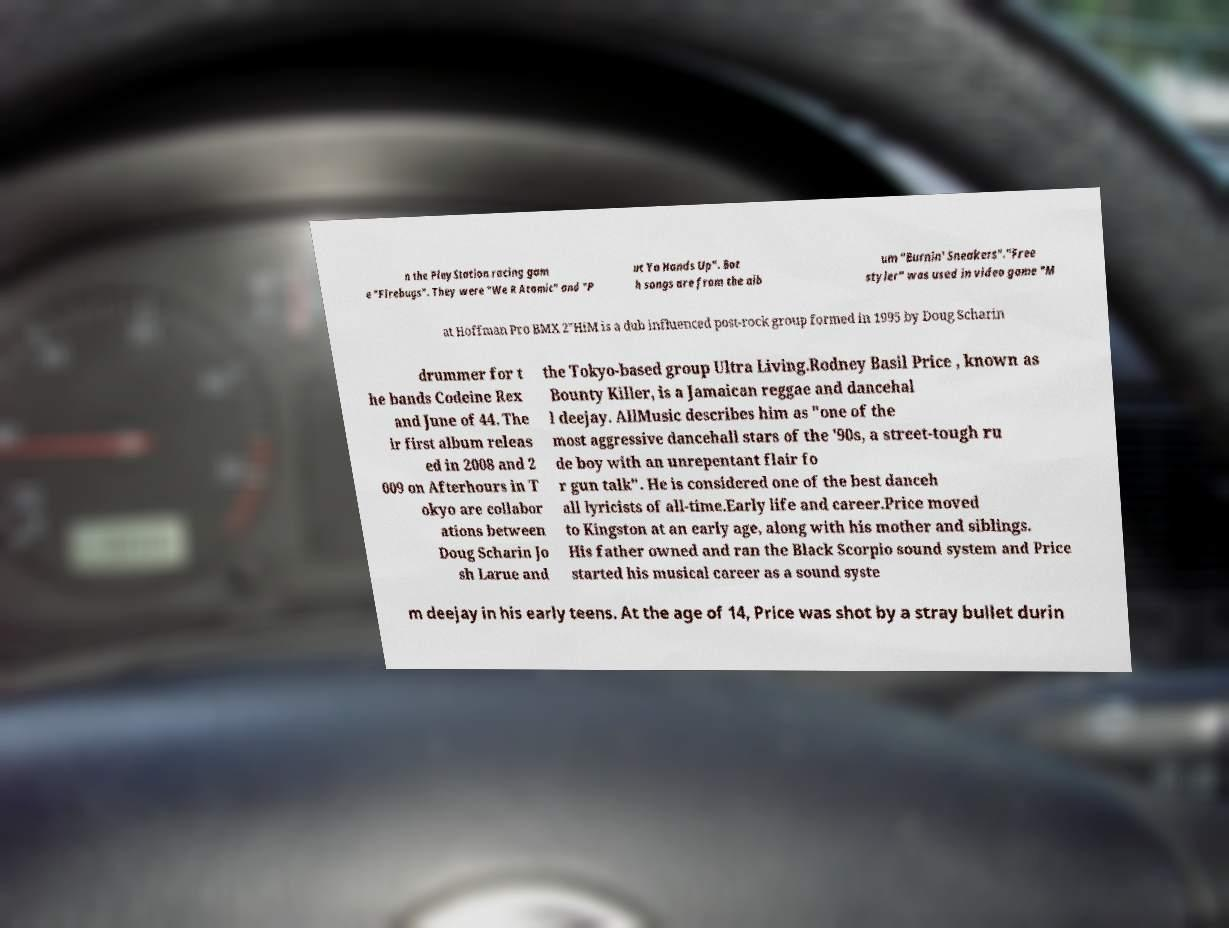I need the written content from this picture converted into text. Can you do that? n the PlayStation racing gam e "Firebugs". They were "We R Atomic" and "P ut Ya Hands Up". Bot h songs are from the alb um "Burnin' Sneakers"."Free styler" was used in video game "M at Hoffman Pro BMX 2"HiM is a dub influenced post-rock group formed in 1995 by Doug Scharin drummer for t he bands Codeine Rex and June of 44. The ir first album releas ed in 2008 and 2 009 on Afterhours in T okyo are collabor ations between Doug Scharin Jo sh Larue and the Tokyo-based group Ultra Living.Rodney Basil Price , known as Bounty Killer, is a Jamaican reggae and dancehal l deejay. AllMusic describes him as "one of the most aggressive dancehall stars of the '90s, a street-tough ru de boy with an unrepentant flair fo r gun talk". He is considered one of the best danceh all lyricists of all-time.Early life and career.Price moved to Kingston at an early age, along with his mother and siblings. His father owned and ran the Black Scorpio sound system and Price started his musical career as a sound syste m deejay in his early teens. At the age of 14, Price was shot by a stray bullet durin 